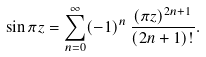Convert formula to latex. <formula><loc_0><loc_0><loc_500><loc_500>\sin \pi z = \sum _ { n = 0 } ^ { \infty } ( - 1 ) ^ { n } \, \frac { ( \pi z ) ^ { 2 n + 1 } } { ( 2 n + 1 ) ! } .</formula> 